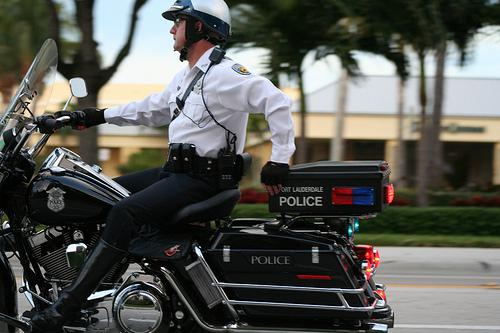Question: who is riding the motorcycle?
Choices:
A. The police officer.
B. A man.
C. A woman.
D. An employee.
Answer with the letter. Answer: A Question: where is the officer?
Choices:
A. On the sidewalk.
B. In the car.
C. In the office.
D. On the motorbike.
Answer with the letter. Answer: D Question: what color are the boots?
Choices:
A. Black.
B. Brown.
C. White.
D. Red.
Answer with the letter. Answer: A Question: why are there red and blue lights?
Choices:
A. To alarm.
B. For emergency.
C. It is northern lights.
D. Police bike.
Answer with the letter. Answer: D 